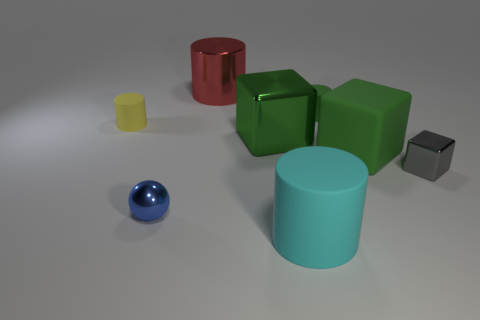Subtract all large red shiny cylinders. How many cylinders are left? 3 Add 1 small yellow matte things. How many objects exist? 9 Subtract all blocks. How many objects are left? 5 Subtract all green blocks. How many blocks are left? 1 Subtract 0 brown blocks. How many objects are left? 8 Subtract 1 cubes. How many cubes are left? 2 Subtract all cyan cubes. Subtract all red spheres. How many cubes are left? 3 Subtract all purple cylinders. How many gray cubes are left? 1 Subtract all metal spheres. Subtract all small blue metal spheres. How many objects are left? 6 Add 6 large cylinders. How many large cylinders are left? 8 